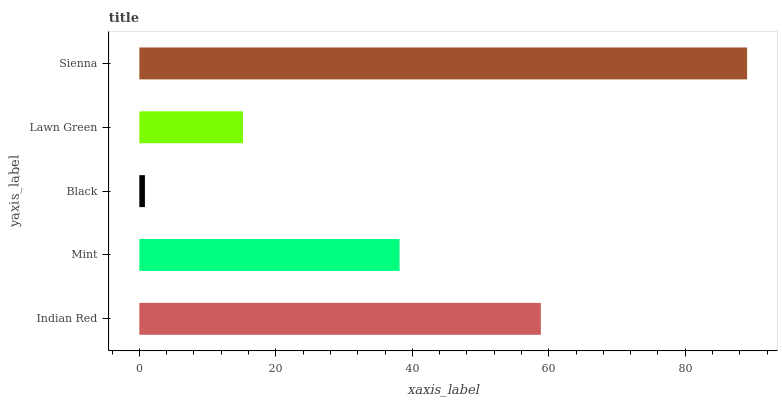Is Black the minimum?
Answer yes or no. Yes. Is Sienna the maximum?
Answer yes or no. Yes. Is Mint the minimum?
Answer yes or no. No. Is Mint the maximum?
Answer yes or no. No. Is Indian Red greater than Mint?
Answer yes or no. Yes. Is Mint less than Indian Red?
Answer yes or no. Yes. Is Mint greater than Indian Red?
Answer yes or no. No. Is Indian Red less than Mint?
Answer yes or no. No. Is Mint the high median?
Answer yes or no. Yes. Is Mint the low median?
Answer yes or no. Yes. Is Sienna the high median?
Answer yes or no. No. Is Black the low median?
Answer yes or no. No. 